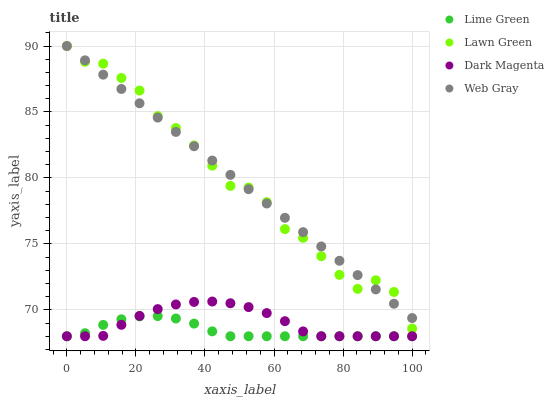Does Lime Green have the minimum area under the curve?
Answer yes or no. Yes. Does Web Gray have the maximum area under the curve?
Answer yes or no. Yes. Does Web Gray have the minimum area under the curve?
Answer yes or no. No. Does Lime Green have the maximum area under the curve?
Answer yes or no. No. Is Web Gray the smoothest?
Answer yes or no. Yes. Is Lawn Green the roughest?
Answer yes or no. Yes. Is Lime Green the smoothest?
Answer yes or no. No. Is Lime Green the roughest?
Answer yes or no. No. Does Lime Green have the lowest value?
Answer yes or no. Yes. Does Web Gray have the lowest value?
Answer yes or no. No. Does Web Gray have the highest value?
Answer yes or no. Yes. Does Lime Green have the highest value?
Answer yes or no. No. Is Dark Magenta less than Lawn Green?
Answer yes or no. Yes. Is Lawn Green greater than Dark Magenta?
Answer yes or no. Yes. Does Web Gray intersect Lawn Green?
Answer yes or no. Yes. Is Web Gray less than Lawn Green?
Answer yes or no. No. Is Web Gray greater than Lawn Green?
Answer yes or no. No. Does Dark Magenta intersect Lawn Green?
Answer yes or no. No. 